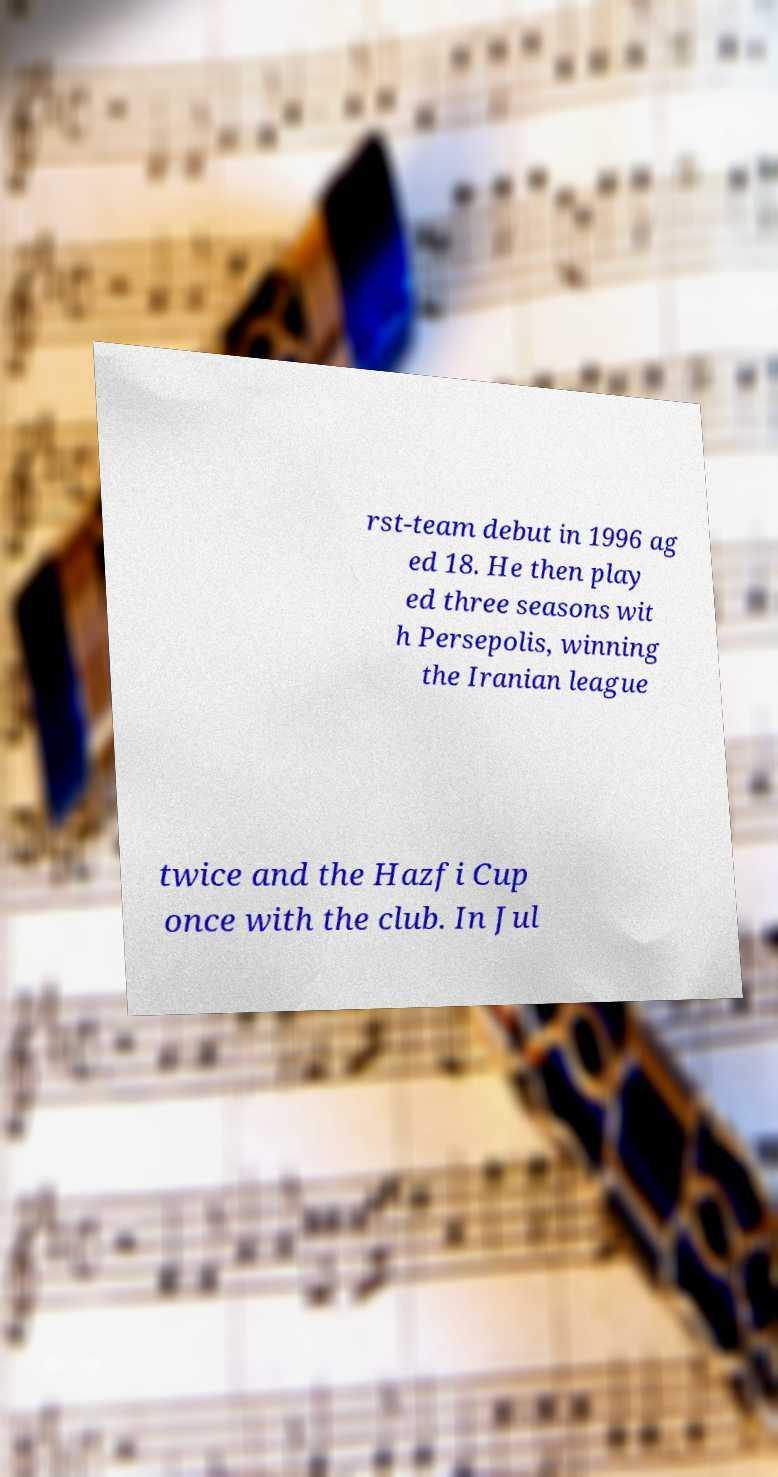There's text embedded in this image that I need extracted. Can you transcribe it verbatim? rst-team debut in 1996 ag ed 18. He then play ed three seasons wit h Persepolis, winning the Iranian league twice and the Hazfi Cup once with the club. In Jul 